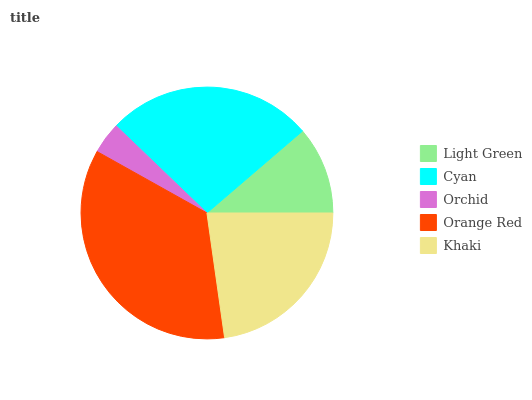Is Orchid the minimum?
Answer yes or no. Yes. Is Orange Red the maximum?
Answer yes or no. Yes. Is Cyan the minimum?
Answer yes or no. No. Is Cyan the maximum?
Answer yes or no. No. Is Cyan greater than Light Green?
Answer yes or no. Yes. Is Light Green less than Cyan?
Answer yes or no. Yes. Is Light Green greater than Cyan?
Answer yes or no. No. Is Cyan less than Light Green?
Answer yes or no. No. Is Khaki the high median?
Answer yes or no. Yes. Is Khaki the low median?
Answer yes or no. Yes. Is Orchid the high median?
Answer yes or no. No. Is Orchid the low median?
Answer yes or no. No. 